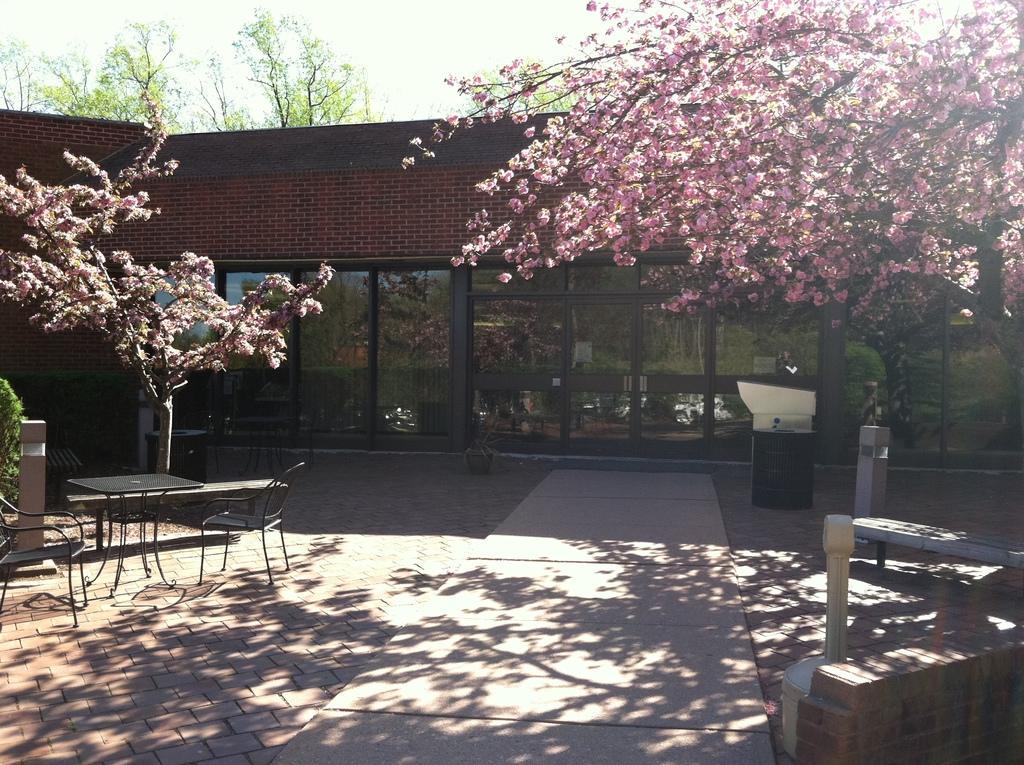In one or two sentences, can you explain what this image depicts? In this picture I can see the path in front, on which there are 2 chairs, a table and other things and in the middle of this picture I can see a building and few trees. In the background I can see the sky. 